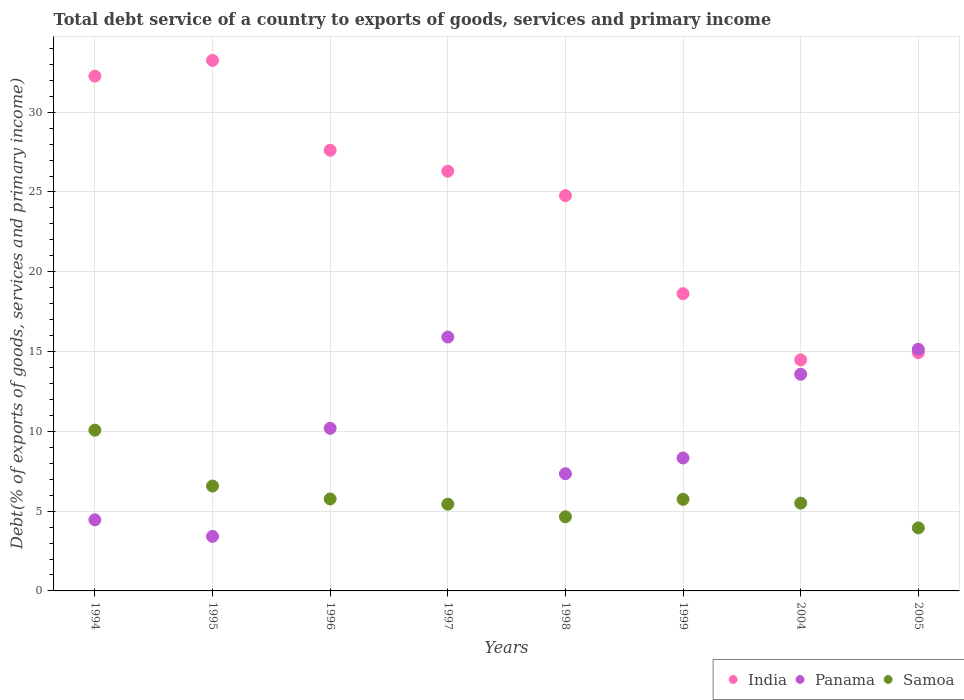How many different coloured dotlines are there?
Offer a very short reply. 3. What is the total debt service in Samoa in 2004?
Provide a succinct answer. 5.5. Across all years, what is the maximum total debt service in Samoa?
Provide a succinct answer. 10.07. Across all years, what is the minimum total debt service in India?
Make the answer very short. 14.48. In which year was the total debt service in Panama maximum?
Offer a terse response. 1997. In which year was the total debt service in Panama minimum?
Offer a terse response. 1995. What is the total total debt service in Panama in the graph?
Offer a terse response. 78.37. What is the difference between the total debt service in India in 1997 and that in 1998?
Make the answer very short. 1.53. What is the difference between the total debt service in Panama in 1998 and the total debt service in India in 1994?
Provide a succinct answer. -24.92. What is the average total debt service in India per year?
Make the answer very short. 24.03. In the year 1995, what is the difference between the total debt service in India and total debt service in Samoa?
Your answer should be very brief. 26.67. In how many years, is the total debt service in India greater than 1 %?
Your response must be concise. 8. What is the ratio of the total debt service in Panama in 1995 to that in 1997?
Make the answer very short. 0.21. Is the difference between the total debt service in India in 1998 and 2004 greater than the difference between the total debt service in Samoa in 1998 and 2004?
Provide a short and direct response. Yes. What is the difference between the highest and the second highest total debt service in India?
Your answer should be compact. 0.99. What is the difference between the highest and the lowest total debt service in Samoa?
Offer a terse response. 6.12. How many dotlines are there?
Your answer should be compact. 3. How many years are there in the graph?
Provide a succinct answer. 8. What is the difference between two consecutive major ticks on the Y-axis?
Give a very brief answer. 5. Are the values on the major ticks of Y-axis written in scientific E-notation?
Your answer should be very brief. No. Does the graph contain any zero values?
Give a very brief answer. No. What is the title of the graph?
Your answer should be very brief. Total debt service of a country to exports of goods, services and primary income. Does "Austria" appear as one of the legend labels in the graph?
Offer a terse response. No. What is the label or title of the Y-axis?
Ensure brevity in your answer.  Debt(% of exports of goods, services and primary income). What is the Debt(% of exports of goods, services and primary income) of India in 1994?
Ensure brevity in your answer.  32.26. What is the Debt(% of exports of goods, services and primary income) of Panama in 1994?
Provide a short and direct response. 4.46. What is the Debt(% of exports of goods, services and primary income) in Samoa in 1994?
Provide a short and direct response. 10.07. What is the Debt(% of exports of goods, services and primary income) of India in 1995?
Keep it short and to the point. 33.25. What is the Debt(% of exports of goods, services and primary income) in Panama in 1995?
Give a very brief answer. 3.42. What is the Debt(% of exports of goods, services and primary income) in Samoa in 1995?
Offer a very short reply. 6.57. What is the Debt(% of exports of goods, services and primary income) of India in 1996?
Make the answer very short. 27.62. What is the Debt(% of exports of goods, services and primary income) in Panama in 1996?
Your response must be concise. 10.19. What is the Debt(% of exports of goods, services and primary income) in Samoa in 1996?
Give a very brief answer. 5.76. What is the Debt(% of exports of goods, services and primary income) of India in 1997?
Offer a very short reply. 26.3. What is the Debt(% of exports of goods, services and primary income) in Panama in 1997?
Ensure brevity in your answer.  15.91. What is the Debt(% of exports of goods, services and primary income) in Samoa in 1997?
Your answer should be very brief. 5.44. What is the Debt(% of exports of goods, services and primary income) in India in 1998?
Your answer should be compact. 24.77. What is the Debt(% of exports of goods, services and primary income) of Panama in 1998?
Your answer should be compact. 7.35. What is the Debt(% of exports of goods, services and primary income) in Samoa in 1998?
Provide a succinct answer. 4.64. What is the Debt(% of exports of goods, services and primary income) in India in 1999?
Your response must be concise. 18.63. What is the Debt(% of exports of goods, services and primary income) of Panama in 1999?
Provide a succinct answer. 8.33. What is the Debt(% of exports of goods, services and primary income) in Samoa in 1999?
Keep it short and to the point. 5.74. What is the Debt(% of exports of goods, services and primary income) in India in 2004?
Ensure brevity in your answer.  14.48. What is the Debt(% of exports of goods, services and primary income) of Panama in 2004?
Make the answer very short. 13.58. What is the Debt(% of exports of goods, services and primary income) of Samoa in 2004?
Provide a succinct answer. 5.5. What is the Debt(% of exports of goods, services and primary income) of India in 2005?
Give a very brief answer. 14.93. What is the Debt(% of exports of goods, services and primary income) in Panama in 2005?
Give a very brief answer. 15.15. What is the Debt(% of exports of goods, services and primary income) of Samoa in 2005?
Your answer should be very brief. 3.95. Across all years, what is the maximum Debt(% of exports of goods, services and primary income) of India?
Keep it short and to the point. 33.25. Across all years, what is the maximum Debt(% of exports of goods, services and primary income) in Panama?
Provide a succinct answer. 15.91. Across all years, what is the maximum Debt(% of exports of goods, services and primary income) of Samoa?
Give a very brief answer. 10.07. Across all years, what is the minimum Debt(% of exports of goods, services and primary income) in India?
Give a very brief answer. 14.48. Across all years, what is the minimum Debt(% of exports of goods, services and primary income) in Panama?
Ensure brevity in your answer.  3.42. Across all years, what is the minimum Debt(% of exports of goods, services and primary income) of Samoa?
Keep it short and to the point. 3.95. What is the total Debt(% of exports of goods, services and primary income) in India in the graph?
Ensure brevity in your answer.  192.24. What is the total Debt(% of exports of goods, services and primary income) in Panama in the graph?
Your answer should be compact. 78.37. What is the total Debt(% of exports of goods, services and primary income) of Samoa in the graph?
Ensure brevity in your answer.  47.69. What is the difference between the Debt(% of exports of goods, services and primary income) of India in 1994 and that in 1995?
Keep it short and to the point. -0.99. What is the difference between the Debt(% of exports of goods, services and primary income) in Panama in 1994 and that in 1995?
Give a very brief answer. 1.04. What is the difference between the Debt(% of exports of goods, services and primary income) of Samoa in 1994 and that in 1995?
Give a very brief answer. 3.5. What is the difference between the Debt(% of exports of goods, services and primary income) in India in 1994 and that in 1996?
Your answer should be compact. 4.64. What is the difference between the Debt(% of exports of goods, services and primary income) in Panama in 1994 and that in 1996?
Provide a succinct answer. -5.73. What is the difference between the Debt(% of exports of goods, services and primary income) in Samoa in 1994 and that in 1996?
Your answer should be compact. 4.31. What is the difference between the Debt(% of exports of goods, services and primary income) in India in 1994 and that in 1997?
Offer a terse response. 5.96. What is the difference between the Debt(% of exports of goods, services and primary income) in Panama in 1994 and that in 1997?
Give a very brief answer. -11.46. What is the difference between the Debt(% of exports of goods, services and primary income) of Samoa in 1994 and that in 1997?
Ensure brevity in your answer.  4.64. What is the difference between the Debt(% of exports of goods, services and primary income) in India in 1994 and that in 1998?
Make the answer very short. 7.49. What is the difference between the Debt(% of exports of goods, services and primary income) of Panama in 1994 and that in 1998?
Give a very brief answer. -2.89. What is the difference between the Debt(% of exports of goods, services and primary income) of Samoa in 1994 and that in 1998?
Your answer should be very brief. 5.43. What is the difference between the Debt(% of exports of goods, services and primary income) of India in 1994 and that in 1999?
Offer a terse response. 13.63. What is the difference between the Debt(% of exports of goods, services and primary income) of Panama in 1994 and that in 1999?
Your answer should be compact. -3.88. What is the difference between the Debt(% of exports of goods, services and primary income) of Samoa in 1994 and that in 1999?
Keep it short and to the point. 4.33. What is the difference between the Debt(% of exports of goods, services and primary income) of India in 1994 and that in 2004?
Offer a very short reply. 17.78. What is the difference between the Debt(% of exports of goods, services and primary income) of Panama in 1994 and that in 2004?
Your response must be concise. -9.12. What is the difference between the Debt(% of exports of goods, services and primary income) of Samoa in 1994 and that in 2004?
Your answer should be compact. 4.57. What is the difference between the Debt(% of exports of goods, services and primary income) of India in 1994 and that in 2005?
Keep it short and to the point. 17.33. What is the difference between the Debt(% of exports of goods, services and primary income) of Panama in 1994 and that in 2005?
Give a very brief answer. -10.69. What is the difference between the Debt(% of exports of goods, services and primary income) of Samoa in 1994 and that in 2005?
Offer a terse response. 6.12. What is the difference between the Debt(% of exports of goods, services and primary income) of India in 1995 and that in 1996?
Keep it short and to the point. 5.63. What is the difference between the Debt(% of exports of goods, services and primary income) in Panama in 1995 and that in 1996?
Offer a terse response. -6.77. What is the difference between the Debt(% of exports of goods, services and primary income) of Samoa in 1995 and that in 1996?
Your response must be concise. 0.81. What is the difference between the Debt(% of exports of goods, services and primary income) of India in 1995 and that in 1997?
Keep it short and to the point. 6.95. What is the difference between the Debt(% of exports of goods, services and primary income) of Panama in 1995 and that in 1997?
Offer a terse response. -12.49. What is the difference between the Debt(% of exports of goods, services and primary income) of Samoa in 1995 and that in 1997?
Make the answer very short. 1.14. What is the difference between the Debt(% of exports of goods, services and primary income) in India in 1995 and that in 1998?
Offer a very short reply. 8.48. What is the difference between the Debt(% of exports of goods, services and primary income) of Panama in 1995 and that in 1998?
Your answer should be compact. -3.93. What is the difference between the Debt(% of exports of goods, services and primary income) in Samoa in 1995 and that in 1998?
Make the answer very short. 1.93. What is the difference between the Debt(% of exports of goods, services and primary income) in India in 1995 and that in 1999?
Offer a terse response. 14.62. What is the difference between the Debt(% of exports of goods, services and primary income) in Panama in 1995 and that in 1999?
Your answer should be very brief. -4.92. What is the difference between the Debt(% of exports of goods, services and primary income) of Samoa in 1995 and that in 1999?
Your answer should be compact. 0.83. What is the difference between the Debt(% of exports of goods, services and primary income) of India in 1995 and that in 2004?
Provide a succinct answer. 18.77. What is the difference between the Debt(% of exports of goods, services and primary income) in Panama in 1995 and that in 2004?
Provide a succinct answer. -10.16. What is the difference between the Debt(% of exports of goods, services and primary income) in Samoa in 1995 and that in 2004?
Offer a very short reply. 1.07. What is the difference between the Debt(% of exports of goods, services and primary income) in India in 1995 and that in 2005?
Your answer should be compact. 18.32. What is the difference between the Debt(% of exports of goods, services and primary income) of Panama in 1995 and that in 2005?
Your answer should be very brief. -11.73. What is the difference between the Debt(% of exports of goods, services and primary income) of Samoa in 1995 and that in 2005?
Keep it short and to the point. 2.62. What is the difference between the Debt(% of exports of goods, services and primary income) in India in 1996 and that in 1997?
Make the answer very short. 1.31. What is the difference between the Debt(% of exports of goods, services and primary income) of Panama in 1996 and that in 1997?
Provide a short and direct response. -5.72. What is the difference between the Debt(% of exports of goods, services and primary income) of Samoa in 1996 and that in 1997?
Keep it short and to the point. 0.33. What is the difference between the Debt(% of exports of goods, services and primary income) of India in 1996 and that in 1998?
Provide a succinct answer. 2.84. What is the difference between the Debt(% of exports of goods, services and primary income) of Panama in 1996 and that in 1998?
Keep it short and to the point. 2.84. What is the difference between the Debt(% of exports of goods, services and primary income) of Samoa in 1996 and that in 1998?
Offer a very short reply. 1.12. What is the difference between the Debt(% of exports of goods, services and primary income) of India in 1996 and that in 1999?
Offer a terse response. 8.99. What is the difference between the Debt(% of exports of goods, services and primary income) of Panama in 1996 and that in 1999?
Provide a short and direct response. 1.86. What is the difference between the Debt(% of exports of goods, services and primary income) of Samoa in 1996 and that in 1999?
Your answer should be compact. 0.02. What is the difference between the Debt(% of exports of goods, services and primary income) of India in 1996 and that in 2004?
Your answer should be compact. 13.14. What is the difference between the Debt(% of exports of goods, services and primary income) in Panama in 1996 and that in 2004?
Provide a succinct answer. -3.39. What is the difference between the Debt(% of exports of goods, services and primary income) of Samoa in 1996 and that in 2004?
Ensure brevity in your answer.  0.26. What is the difference between the Debt(% of exports of goods, services and primary income) in India in 1996 and that in 2005?
Give a very brief answer. 12.69. What is the difference between the Debt(% of exports of goods, services and primary income) in Panama in 1996 and that in 2005?
Your answer should be compact. -4.96. What is the difference between the Debt(% of exports of goods, services and primary income) of Samoa in 1996 and that in 2005?
Your answer should be compact. 1.81. What is the difference between the Debt(% of exports of goods, services and primary income) in India in 1997 and that in 1998?
Provide a succinct answer. 1.53. What is the difference between the Debt(% of exports of goods, services and primary income) of Panama in 1997 and that in 1998?
Your answer should be very brief. 8.57. What is the difference between the Debt(% of exports of goods, services and primary income) in Samoa in 1997 and that in 1998?
Your answer should be very brief. 0.79. What is the difference between the Debt(% of exports of goods, services and primary income) in India in 1997 and that in 1999?
Keep it short and to the point. 7.67. What is the difference between the Debt(% of exports of goods, services and primary income) of Panama in 1997 and that in 1999?
Offer a very short reply. 7.58. What is the difference between the Debt(% of exports of goods, services and primary income) in Samoa in 1997 and that in 1999?
Keep it short and to the point. -0.3. What is the difference between the Debt(% of exports of goods, services and primary income) of India in 1997 and that in 2004?
Offer a terse response. 11.82. What is the difference between the Debt(% of exports of goods, services and primary income) in Panama in 1997 and that in 2004?
Provide a short and direct response. 2.33. What is the difference between the Debt(% of exports of goods, services and primary income) of Samoa in 1997 and that in 2004?
Offer a terse response. -0.06. What is the difference between the Debt(% of exports of goods, services and primary income) in India in 1997 and that in 2005?
Offer a terse response. 11.37. What is the difference between the Debt(% of exports of goods, services and primary income) of Panama in 1997 and that in 2005?
Ensure brevity in your answer.  0.76. What is the difference between the Debt(% of exports of goods, services and primary income) in Samoa in 1997 and that in 2005?
Ensure brevity in your answer.  1.49. What is the difference between the Debt(% of exports of goods, services and primary income) in India in 1998 and that in 1999?
Offer a terse response. 6.15. What is the difference between the Debt(% of exports of goods, services and primary income) in Panama in 1998 and that in 1999?
Give a very brief answer. -0.99. What is the difference between the Debt(% of exports of goods, services and primary income) in Samoa in 1998 and that in 1999?
Keep it short and to the point. -1.1. What is the difference between the Debt(% of exports of goods, services and primary income) in India in 1998 and that in 2004?
Your answer should be compact. 10.29. What is the difference between the Debt(% of exports of goods, services and primary income) in Panama in 1998 and that in 2004?
Your answer should be compact. -6.23. What is the difference between the Debt(% of exports of goods, services and primary income) in Samoa in 1998 and that in 2004?
Offer a terse response. -0.86. What is the difference between the Debt(% of exports of goods, services and primary income) in India in 1998 and that in 2005?
Your answer should be compact. 9.84. What is the difference between the Debt(% of exports of goods, services and primary income) of Panama in 1998 and that in 2005?
Offer a terse response. -7.8. What is the difference between the Debt(% of exports of goods, services and primary income) of Samoa in 1998 and that in 2005?
Provide a short and direct response. 0.69. What is the difference between the Debt(% of exports of goods, services and primary income) of India in 1999 and that in 2004?
Provide a short and direct response. 4.15. What is the difference between the Debt(% of exports of goods, services and primary income) of Panama in 1999 and that in 2004?
Provide a succinct answer. -5.25. What is the difference between the Debt(% of exports of goods, services and primary income) of Samoa in 1999 and that in 2004?
Your response must be concise. 0.24. What is the difference between the Debt(% of exports of goods, services and primary income) in India in 1999 and that in 2005?
Keep it short and to the point. 3.7. What is the difference between the Debt(% of exports of goods, services and primary income) of Panama in 1999 and that in 2005?
Offer a very short reply. -6.81. What is the difference between the Debt(% of exports of goods, services and primary income) in Samoa in 1999 and that in 2005?
Provide a succinct answer. 1.79. What is the difference between the Debt(% of exports of goods, services and primary income) in India in 2004 and that in 2005?
Offer a terse response. -0.45. What is the difference between the Debt(% of exports of goods, services and primary income) in Panama in 2004 and that in 2005?
Your response must be concise. -1.57. What is the difference between the Debt(% of exports of goods, services and primary income) of Samoa in 2004 and that in 2005?
Provide a short and direct response. 1.55. What is the difference between the Debt(% of exports of goods, services and primary income) of India in 1994 and the Debt(% of exports of goods, services and primary income) of Panama in 1995?
Your response must be concise. 28.84. What is the difference between the Debt(% of exports of goods, services and primary income) of India in 1994 and the Debt(% of exports of goods, services and primary income) of Samoa in 1995?
Your answer should be very brief. 25.69. What is the difference between the Debt(% of exports of goods, services and primary income) in Panama in 1994 and the Debt(% of exports of goods, services and primary income) in Samoa in 1995?
Give a very brief answer. -2.12. What is the difference between the Debt(% of exports of goods, services and primary income) of India in 1994 and the Debt(% of exports of goods, services and primary income) of Panama in 1996?
Provide a short and direct response. 22.07. What is the difference between the Debt(% of exports of goods, services and primary income) in India in 1994 and the Debt(% of exports of goods, services and primary income) in Samoa in 1996?
Your answer should be very brief. 26.5. What is the difference between the Debt(% of exports of goods, services and primary income) of Panama in 1994 and the Debt(% of exports of goods, services and primary income) of Samoa in 1996?
Provide a succinct answer. -1.31. What is the difference between the Debt(% of exports of goods, services and primary income) in India in 1994 and the Debt(% of exports of goods, services and primary income) in Panama in 1997?
Keep it short and to the point. 16.35. What is the difference between the Debt(% of exports of goods, services and primary income) in India in 1994 and the Debt(% of exports of goods, services and primary income) in Samoa in 1997?
Make the answer very short. 26.82. What is the difference between the Debt(% of exports of goods, services and primary income) of Panama in 1994 and the Debt(% of exports of goods, services and primary income) of Samoa in 1997?
Keep it short and to the point. -0.98. What is the difference between the Debt(% of exports of goods, services and primary income) in India in 1994 and the Debt(% of exports of goods, services and primary income) in Panama in 1998?
Offer a very short reply. 24.92. What is the difference between the Debt(% of exports of goods, services and primary income) of India in 1994 and the Debt(% of exports of goods, services and primary income) of Samoa in 1998?
Your answer should be compact. 27.62. What is the difference between the Debt(% of exports of goods, services and primary income) of Panama in 1994 and the Debt(% of exports of goods, services and primary income) of Samoa in 1998?
Keep it short and to the point. -0.19. What is the difference between the Debt(% of exports of goods, services and primary income) in India in 1994 and the Debt(% of exports of goods, services and primary income) in Panama in 1999?
Ensure brevity in your answer.  23.93. What is the difference between the Debt(% of exports of goods, services and primary income) of India in 1994 and the Debt(% of exports of goods, services and primary income) of Samoa in 1999?
Your answer should be very brief. 26.52. What is the difference between the Debt(% of exports of goods, services and primary income) in Panama in 1994 and the Debt(% of exports of goods, services and primary income) in Samoa in 1999?
Your response must be concise. -1.28. What is the difference between the Debt(% of exports of goods, services and primary income) of India in 1994 and the Debt(% of exports of goods, services and primary income) of Panama in 2004?
Make the answer very short. 18.68. What is the difference between the Debt(% of exports of goods, services and primary income) in India in 1994 and the Debt(% of exports of goods, services and primary income) in Samoa in 2004?
Your response must be concise. 26.76. What is the difference between the Debt(% of exports of goods, services and primary income) in Panama in 1994 and the Debt(% of exports of goods, services and primary income) in Samoa in 2004?
Provide a short and direct response. -1.05. What is the difference between the Debt(% of exports of goods, services and primary income) in India in 1994 and the Debt(% of exports of goods, services and primary income) in Panama in 2005?
Provide a succinct answer. 17.11. What is the difference between the Debt(% of exports of goods, services and primary income) in India in 1994 and the Debt(% of exports of goods, services and primary income) in Samoa in 2005?
Make the answer very short. 28.31. What is the difference between the Debt(% of exports of goods, services and primary income) in Panama in 1994 and the Debt(% of exports of goods, services and primary income) in Samoa in 2005?
Your response must be concise. 0.51. What is the difference between the Debt(% of exports of goods, services and primary income) in India in 1995 and the Debt(% of exports of goods, services and primary income) in Panama in 1996?
Ensure brevity in your answer.  23.06. What is the difference between the Debt(% of exports of goods, services and primary income) of India in 1995 and the Debt(% of exports of goods, services and primary income) of Samoa in 1996?
Provide a succinct answer. 27.48. What is the difference between the Debt(% of exports of goods, services and primary income) in Panama in 1995 and the Debt(% of exports of goods, services and primary income) in Samoa in 1996?
Your answer should be very brief. -2.35. What is the difference between the Debt(% of exports of goods, services and primary income) of India in 1995 and the Debt(% of exports of goods, services and primary income) of Panama in 1997?
Your answer should be compact. 17.34. What is the difference between the Debt(% of exports of goods, services and primary income) in India in 1995 and the Debt(% of exports of goods, services and primary income) in Samoa in 1997?
Provide a succinct answer. 27.81. What is the difference between the Debt(% of exports of goods, services and primary income) in Panama in 1995 and the Debt(% of exports of goods, services and primary income) in Samoa in 1997?
Provide a succinct answer. -2.02. What is the difference between the Debt(% of exports of goods, services and primary income) in India in 1995 and the Debt(% of exports of goods, services and primary income) in Panama in 1998?
Give a very brief answer. 25.9. What is the difference between the Debt(% of exports of goods, services and primary income) of India in 1995 and the Debt(% of exports of goods, services and primary income) of Samoa in 1998?
Give a very brief answer. 28.6. What is the difference between the Debt(% of exports of goods, services and primary income) of Panama in 1995 and the Debt(% of exports of goods, services and primary income) of Samoa in 1998?
Provide a short and direct response. -1.23. What is the difference between the Debt(% of exports of goods, services and primary income) in India in 1995 and the Debt(% of exports of goods, services and primary income) in Panama in 1999?
Your answer should be compact. 24.92. What is the difference between the Debt(% of exports of goods, services and primary income) in India in 1995 and the Debt(% of exports of goods, services and primary income) in Samoa in 1999?
Provide a short and direct response. 27.51. What is the difference between the Debt(% of exports of goods, services and primary income) in Panama in 1995 and the Debt(% of exports of goods, services and primary income) in Samoa in 1999?
Offer a very short reply. -2.32. What is the difference between the Debt(% of exports of goods, services and primary income) in India in 1995 and the Debt(% of exports of goods, services and primary income) in Panama in 2004?
Give a very brief answer. 19.67. What is the difference between the Debt(% of exports of goods, services and primary income) in India in 1995 and the Debt(% of exports of goods, services and primary income) in Samoa in 2004?
Offer a terse response. 27.75. What is the difference between the Debt(% of exports of goods, services and primary income) in Panama in 1995 and the Debt(% of exports of goods, services and primary income) in Samoa in 2004?
Make the answer very short. -2.09. What is the difference between the Debt(% of exports of goods, services and primary income) in India in 1995 and the Debt(% of exports of goods, services and primary income) in Panama in 2005?
Provide a short and direct response. 18.1. What is the difference between the Debt(% of exports of goods, services and primary income) of India in 1995 and the Debt(% of exports of goods, services and primary income) of Samoa in 2005?
Offer a terse response. 29.3. What is the difference between the Debt(% of exports of goods, services and primary income) of Panama in 1995 and the Debt(% of exports of goods, services and primary income) of Samoa in 2005?
Offer a terse response. -0.53. What is the difference between the Debt(% of exports of goods, services and primary income) of India in 1996 and the Debt(% of exports of goods, services and primary income) of Panama in 1997?
Keep it short and to the point. 11.7. What is the difference between the Debt(% of exports of goods, services and primary income) of India in 1996 and the Debt(% of exports of goods, services and primary income) of Samoa in 1997?
Your response must be concise. 22.18. What is the difference between the Debt(% of exports of goods, services and primary income) of Panama in 1996 and the Debt(% of exports of goods, services and primary income) of Samoa in 1997?
Keep it short and to the point. 4.75. What is the difference between the Debt(% of exports of goods, services and primary income) in India in 1996 and the Debt(% of exports of goods, services and primary income) in Panama in 1998?
Provide a short and direct response. 20.27. What is the difference between the Debt(% of exports of goods, services and primary income) of India in 1996 and the Debt(% of exports of goods, services and primary income) of Samoa in 1998?
Make the answer very short. 22.97. What is the difference between the Debt(% of exports of goods, services and primary income) of Panama in 1996 and the Debt(% of exports of goods, services and primary income) of Samoa in 1998?
Your answer should be compact. 5.54. What is the difference between the Debt(% of exports of goods, services and primary income) of India in 1996 and the Debt(% of exports of goods, services and primary income) of Panama in 1999?
Give a very brief answer. 19.28. What is the difference between the Debt(% of exports of goods, services and primary income) of India in 1996 and the Debt(% of exports of goods, services and primary income) of Samoa in 1999?
Provide a succinct answer. 21.88. What is the difference between the Debt(% of exports of goods, services and primary income) in Panama in 1996 and the Debt(% of exports of goods, services and primary income) in Samoa in 1999?
Ensure brevity in your answer.  4.45. What is the difference between the Debt(% of exports of goods, services and primary income) of India in 1996 and the Debt(% of exports of goods, services and primary income) of Panama in 2004?
Your answer should be very brief. 14.04. What is the difference between the Debt(% of exports of goods, services and primary income) in India in 1996 and the Debt(% of exports of goods, services and primary income) in Samoa in 2004?
Your answer should be very brief. 22.11. What is the difference between the Debt(% of exports of goods, services and primary income) in Panama in 1996 and the Debt(% of exports of goods, services and primary income) in Samoa in 2004?
Your answer should be very brief. 4.69. What is the difference between the Debt(% of exports of goods, services and primary income) in India in 1996 and the Debt(% of exports of goods, services and primary income) in Panama in 2005?
Keep it short and to the point. 12.47. What is the difference between the Debt(% of exports of goods, services and primary income) of India in 1996 and the Debt(% of exports of goods, services and primary income) of Samoa in 2005?
Give a very brief answer. 23.67. What is the difference between the Debt(% of exports of goods, services and primary income) in Panama in 1996 and the Debt(% of exports of goods, services and primary income) in Samoa in 2005?
Provide a succinct answer. 6.24. What is the difference between the Debt(% of exports of goods, services and primary income) of India in 1997 and the Debt(% of exports of goods, services and primary income) of Panama in 1998?
Offer a very short reply. 18.96. What is the difference between the Debt(% of exports of goods, services and primary income) in India in 1997 and the Debt(% of exports of goods, services and primary income) in Samoa in 1998?
Offer a very short reply. 21.66. What is the difference between the Debt(% of exports of goods, services and primary income) in Panama in 1997 and the Debt(% of exports of goods, services and primary income) in Samoa in 1998?
Give a very brief answer. 11.27. What is the difference between the Debt(% of exports of goods, services and primary income) of India in 1997 and the Debt(% of exports of goods, services and primary income) of Panama in 1999?
Your answer should be compact. 17.97. What is the difference between the Debt(% of exports of goods, services and primary income) of India in 1997 and the Debt(% of exports of goods, services and primary income) of Samoa in 1999?
Provide a succinct answer. 20.56. What is the difference between the Debt(% of exports of goods, services and primary income) in Panama in 1997 and the Debt(% of exports of goods, services and primary income) in Samoa in 1999?
Offer a terse response. 10.17. What is the difference between the Debt(% of exports of goods, services and primary income) in India in 1997 and the Debt(% of exports of goods, services and primary income) in Panama in 2004?
Offer a terse response. 12.72. What is the difference between the Debt(% of exports of goods, services and primary income) of India in 1997 and the Debt(% of exports of goods, services and primary income) of Samoa in 2004?
Ensure brevity in your answer.  20.8. What is the difference between the Debt(% of exports of goods, services and primary income) in Panama in 1997 and the Debt(% of exports of goods, services and primary income) in Samoa in 2004?
Offer a terse response. 10.41. What is the difference between the Debt(% of exports of goods, services and primary income) of India in 1997 and the Debt(% of exports of goods, services and primary income) of Panama in 2005?
Your answer should be compact. 11.16. What is the difference between the Debt(% of exports of goods, services and primary income) in India in 1997 and the Debt(% of exports of goods, services and primary income) in Samoa in 2005?
Offer a very short reply. 22.35. What is the difference between the Debt(% of exports of goods, services and primary income) of Panama in 1997 and the Debt(% of exports of goods, services and primary income) of Samoa in 2005?
Offer a terse response. 11.96. What is the difference between the Debt(% of exports of goods, services and primary income) in India in 1998 and the Debt(% of exports of goods, services and primary income) in Panama in 1999?
Provide a short and direct response. 16.44. What is the difference between the Debt(% of exports of goods, services and primary income) of India in 1998 and the Debt(% of exports of goods, services and primary income) of Samoa in 1999?
Offer a very short reply. 19.03. What is the difference between the Debt(% of exports of goods, services and primary income) of Panama in 1998 and the Debt(% of exports of goods, services and primary income) of Samoa in 1999?
Offer a terse response. 1.6. What is the difference between the Debt(% of exports of goods, services and primary income) of India in 1998 and the Debt(% of exports of goods, services and primary income) of Panama in 2004?
Offer a terse response. 11.19. What is the difference between the Debt(% of exports of goods, services and primary income) of India in 1998 and the Debt(% of exports of goods, services and primary income) of Samoa in 2004?
Provide a succinct answer. 19.27. What is the difference between the Debt(% of exports of goods, services and primary income) in Panama in 1998 and the Debt(% of exports of goods, services and primary income) in Samoa in 2004?
Your answer should be very brief. 1.84. What is the difference between the Debt(% of exports of goods, services and primary income) of India in 1998 and the Debt(% of exports of goods, services and primary income) of Panama in 2005?
Give a very brief answer. 9.63. What is the difference between the Debt(% of exports of goods, services and primary income) in India in 1998 and the Debt(% of exports of goods, services and primary income) in Samoa in 2005?
Make the answer very short. 20.82. What is the difference between the Debt(% of exports of goods, services and primary income) in Panama in 1998 and the Debt(% of exports of goods, services and primary income) in Samoa in 2005?
Offer a very short reply. 3.4. What is the difference between the Debt(% of exports of goods, services and primary income) of India in 1999 and the Debt(% of exports of goods, services and primary income) of Panama in 2004?
Your response must be concise. 5.05. What is the difference between the Debt(% of exports of goods, services and primary income) of India in 1999 and the Debt(% of exports of goods, services and primary income) of Samoa in 2004?
Make the answer very short. 13.12. What is the difference between the Debt(% of exports of goods, services and primary income) in Panama in 1999 and the Debt(% of exports of goods, services and primary income) in Samoa in 2004?
Offer a very short reply. 2.83. What is the difference between the Debt(% of exports of goods, services and primary income) in India in 1999 and the Debt(% of exports of goods, services and primary income) in Panama in 2005?
Ensure brevity in your answer.  3.48. What is the difference between the Debt(% of exports of goods, services and primary income) in India in 1999 and the Debt(% of exports of goods, services and primary income) in Samoa in 2005?
Your answer should be compact. 14.68. What is the difference between the Debt(% of exports of goods, services and primary income) of Panama in 1999 and the Debt(% of exports of goods, services and primary income) of Samoa in 2005?
Give a very brief answer. 4.38. What is the difference between the Debt(% of exports of goods, services and primary income) of India in 2004 and the Debt(% of exports of goods, services and primary income) of Panama in 2005?
Your answer should be compact. -0.67. What is the difference between the Debt(% of exports of goods, services and primary income) in India in 2004 and the Debt(% of exports of goods, services and primary income) in Samoa in 2005?
Offer a very short reply. 10.53. What is the difference between the Debt(% of exports of goods, services and primary income) of Panama in 2004 and the Debt(% of exports of goods, services and primary income) of Samoa in 2005?
Provide a short and direct response. 9.63. What is the average Debt(% of exports of goods, services and primary income) in India per year?
Offer a terse response. 24.03. What is the average Debt(% of exports of goods, services and primary income) in Panama per year?
Your answer should be very brief. 9.8. What is the average Debt(% of exports of goods, services and primary income) in Samoa per year?
Provide a short and direct response. 5.96. In the year 1994, what is the difference between the Debt(% of exports of goods, services and primary income) in India and Debt(% of exports of goods, services and primary income) in Panama?
Provide a short and direct response. 27.81. In the year 1994, what is the difference between the Debt(% of exports of goods, services and primary income) of India and Debt(% of exports of goods, services and primary income) of Samoa?
Keep it short and to the point. 22.19. In the year 1994, what is the difference between the Debt(% of exports of goods, services and primary income) in Panama and Debt(% of exports of goods, services and primary income) in Samoa?
Offer a very short reply. -5.62. In the year 1995, what is the difference between the Debt(% of exports of goods, services and primary income) in India and Debt(% of exports of goods, services and primary income) in Panama?
Offer a very short reply. 29.83. In the year 1995, what is the difference between the Debt(% of exports of goods, services and primary income) of India and Debt(% of exports of goods, services and primary income) of Samoa?
Keep it short and to the point. 26.67. In the year 1995, what is the difference between the Debt(% of exports of goods, services and primary income) of Panama and Debt(% of exports of goods, services and primary income) of Samoa?
Offer a very short reply. -3.16. In the year 1996, what is the difference between the Debt(% of exports of goods, services and primary income) of India and Debt(% of exports of goods, services and primary income) of Panama?
Provide a short and direct response. 17.43. In the year 1996, what is the difference between the Debt(% of exports of goods, services and primary income) in India and Debt(% of exports of goods, services and primary income) in Samoa?
Make the answer very short. 21.85. In the year 1996, what is the difference between the Debt(% of exports of goods, services and primary income) of Panama and Debt(% of exports of goods, services and primary income) of Samoa?
Keep it short and to the point. 4.43. In the year 1997, what is the difference between the Debt(% of exports of goods, services and primary income) in India and Debt(% of exports of goods, services and primary income) in Panama?
Give a very brief answer. 10.39. In the year 1997, what is the difference between the Debt(% of exports of goods, services and primary income) of India and Debt(% of exports of goods, services and primary income) of Samoa?
Make the answer very short. 20.86. In the year 1997, what is the difference between the Debt(% of exports of goods, services and primary income) of Panama and Debt(% of exports of goods, services and primary income) of Samoa?
Provide a short and direct response. 10.47. In the year 1998, what is the difference between the Debt(% of exports of goods, services and primary income) of India and Debt(% of exports of goods, services and primary income) of Panama?
Your answer should be very brief. 17.43. In the year 1998, what is the difference between the Debt(% of exports of goods, services and primary income) in India and Debt(% of exports of goods, services and primary income) in Samoa?
Give a very brief answer. 20.13. In the year 1998, what is the difference between the Debt(% of exports of goods, services and primary income) of Panama and Debt(% of exports of goods, services and primary income) of Samoa?
Make the answer very short. 2.7. In the year 1999, what is the difference between the Debt(% of exports of goods, services and primary income) of India and Debt(% of exports of goods, services and primary income) of Panama?
Provide a short and direct response. 10.29. In the year 1999, what is the difference between the Debt(% of exports of goods, services and primary income) of India and Debt(% of exports of goods, services and primary income) of Samoa?
Give a very brief answer. 12.89. In the year 1999, what is the difference between the Debt(% of exports of goods, services and primary income) in Panama and Debt(% of exports of goods, services and primary income) in Samoa?
Keep it short and to the point. 2.59. In the year 2004, what is the difference between the Debt(% of exports of goods, services and primary income) in India and Debt(% of exports of goods, services and primary income) in Panama?
Provide a succinct answer. 0.9. In the year 2004, what is the difference between the Debt(% of exports of goods, services and primary income) of India and Debt(% of exports of goods, services and primary income) of Samoa?
Ensure brevity in your answer.  8.98. In the year 2004, what is the difference between the Debt(% of exports of goods, services and primary income) in Panama and Debt(% of exports of goods, services and primary income) in Samoa?
Provide a succinct answer. 8.08. In the year 2005, what is the difference between the Debt(% of exports of goods, services and primary income) of India and Debt(% of exports of goods, services and primary income) of Panama?
Offer a terse response. -0.22. In the year 2005, what is the difference between the Debt(% of exports of goods, services and primary income) of India and Debt(% of exports of goods, services and primary income) of Samoa?
Your response must be concise. 10.98. In the year 2005, what is the difference between the Debt(% of exports of goods, services and primary income) of Panama and Debt(% of exports of goods, services and primary income) of Samoa?
Provide a short and direct response. 11.2. What is the ratio of the Debt(% of exports of goods, services and primary income) of India in 1994 to that in 1995?
Keep it short and to the point. 0.97. What is the ratio of the Debt(% of exports of goods, services and primary income) in Panama in 1994 to that in 1995?
Make the answer very short. 1.3. What is the ratio of the Debt(% of exports of goods, services and primary income) of Samoa in 1994 to that in 1995?
Make the answer very short. 1.53. What is the ratio of the Debt(% of exports of goods, services and primary income) of India in 1994 to that in 1996?
Make the answer very short. 1.17. What is the ratio of the Debt(% of exports of goods, services and primary income) in Panama in 1994 to that in 1996?
Your answer should be very brief. 0.44. What is the ratio of the Debt(% of exports of goods, services and primary income) of Samoa in 1994 to that in 1996?
Keep it short and to the point. 1.75. What is the ratio of the Debt(% of exports of goods, services and primary income) of India in 1994 to that in 1997?
Ensure brevity in your answer.  1.23. What is the ratio of the Debt(% of exports of goods, services and primary income) in Panama in 1994 to that in 1997?
Provide a succinct answer. 0.28. What is the ratio of the Debt(% of exports of goods, services and primary income) of Samoa in 1994 to that in 1997?
Make the answer very short. 1.85. What is the ratio of the Debt(% of exports of goods, services and primary income) in India in 1994 to that in 1998?
Your response must be concise. 1.3. What is the ratio of the Debt(% of exports of goods, services and primary income) of Panama in 1994 to that in 1998?
Provide a succinct answer. 0.61. What is the ratio of the Debt(% of exports of goods, services and primary income) of Samoa in 1994 to that in 1998?
Give a very brief answer. 2.17. What is the ratio of the Debt(% of exports of goods, services and primary income) of India in 1994 to that in 1999?
Keep it short and to the point. 1.73. What is the ratio of the Debt(% of exports of goods, services and primary income) in Panama in 1994 to that in 1999?
Your response must be concise. 0.53. What is the ratio of the Debt(% of exports of goods, services and primary income) in Samoa in 1994 to that in 1999?
Offer a very short reply. 1.75. What is the ratio of the Debt(% of exports of goods, services and primary income) of India in 1994 to that in 2004?
Provide a short and direct response. 2.23. What is the ratio of the Debt(% of exports of goods, services and primary income) in Panama in 1994 to that in 2004?
Ensure brevity in your answer.  0.33. What is the ratio of the Debt(% of exports of goods, services and primary income) in Samoa in 1994 to that in 2004?
Offer a very short reply. 1.83. What is the ratio of the Debt(% of exports of goods, services and primary income) of India in 1994 to that in 2005?
Ensure brevity in your answer.  2.16. What is the ratio of the Debt(% of exports of goods, services and primary income) in Panama in 1994 to that in 2005?
Make the answer very short. 0.29. What is the ratio of the Debt(% of exports of goods, services and primary income) of Samoa in 1994 to that in 2005?
Make the answer very short. 2.55. What is the ratio of the Debt(% of exports of goods, services and primary income) of India in 1995 to that in 1996?
Provide a succinct answer. 1.2. What is the ratio of the Debt(% of exports of goods, services and primary income) of Panama in 1995 to that in 1996?
Your answer should be compact. 0.34. What is the ratio of the Debt(% of exports of goods, services and primary income) in Samoa in 1995 to that in 1996?
Your answer should be very brief. 1.14. What is the ratio of the Debt(% of exports of goods, services and primary income) of India in 1995 to that in 1997?
Your response must be concise. 1.26. What is the ratio of the Debt(% of exports of goods, services and primary income) of Panama in 1995 to that in 1997?
Your response must be concise. 0.21. What is the ratio of the Debt(% of exports of goods, services and primary income) of Samoa in 1995 to that in 1997?
Offer a terse response. 1.21. What is the ratio of the Debt(% of exports of goods, services and primary income) in India in 1995 to that in 1998?
Ensure brevity in your answer.  1.34. What is the ratio of the Debt(% of exports of goods, services and primary income) of Panama in 1995 to that in 1998?
Your answer should be compact. 0.47. What is the ratio of the Debt(% of exports of goods, services and primary income) of Samoa in 1995 to that in 1998?
Your response must be concise. 1.42. What is the ratio of the Debt(% of exports of goods, services and primary income) in India in 1995 to that in 1999?
Provide a short and direct response. 1.78. What is the ratio of the Debt(% of exports of goods, services and primary income) of Panama in 1995 to that in 1999?
Offer a very short reply. 0.41. What is the ratio of the Debt(% of exports of goods, services and primary income) of Samoa in 1995 to that in 1999?
Your answer should be very brief. 1.15. What is the ratio of the Debt(% of exports of goods, services and primary income) in India in 1995 to that in 2004?
Offer a very short reply. 2.3. What is the ratio of the Debt(% of exports of goods, services and primary income) of Panama in 1995 to that in 2004?
Your response must be concise. 0.25. What is the ratio of the Debt(% of exports of goods, services and primary income) of Samoa in 1995 to that in 2004?
Your response must be concise. 1.19. What is the ratio of the Debt(% of exports of goods, services and primary income) of India in 1995 to that in 2005?
Ensure brevity in your answer.  2.23. What is the ratio of the Debt(% of exports of goods, services and primary income) in Panama in 1995 to that in 2005?
Provide a succinct answer. 0.23. What is the ratio of the Debt(% of exports of goods, services and primary income) in Samoa in 1995 to that in 2005?
Provide a succinct answer. 1.66. What is the ratio of the Debt(% of exports of goods, services and primary income) of India in 1996 to that in 1997?
Offer a very short reply. 1.05. What is the ratio of the Debt(% of exports of goods, services and primary income) of Panama in 1996 to that in 1997?
Offer a very short reply. 0.64. What is the ratio of the Debt(% of exports of goods, services and primary income) in Samoa in 1996 to that in 1997?
Your answer should be compact. 1.06. What is the ratio of the Debt(% of exports of goods, services and primary income) in India in 1996 to that in 1998?
Make the answer very short. 1.11. What is the ratio of the Debt(% of exports of goods, services and primary income) in Panama in 1996 to that in 1998?
Offer a terse response. 1.39. What is the ratio of the Debt(% of exports of goods, services and primary income) in Samoa in 1996 to that in 1998?
Your answer should be compact. 1.24. What is the ratio of the Debt(% of exports of goods, services and primary income) in India in 1996 to that in 1999?
Make the answer very short. 1.48. What is the ratio of the Debt(% of exports of goods, services and primary income) of Panama in 1996 to that in 1999?
Make the answer very short. 1.22. What is the ratio of the Debt(% of exports of goods, services and primary income) in Samoa in 1996 to that in 1999?
Offer a very short reply. 1. What is the ratio of the Debt(% of exports of goods, services and primary income) of India in 1996 to that in 2004?
Give a very brief answer. 1.91. What is the ratio of the Debt(% of exports of goods, services and primary income) of Panama in 1996 to that in 2004?
Keep it short and to the point. 0.75. What is the ratio of the Debt(% of exports of goods, services and primary income) in Samoa in 1996 to that in 2004?
Your answer should be compact. 1.05. What is the ratio of the Debt(% of exports of goods, services and primary income) in India in 1996 to that in 2005?
Your answer should be very brief. 1.85. What is the ratio of the Debt(% of exports of goods, services and primary income) of Panama in 1996 to that in 2005?
Your response must be concise. 0.67. What is the ratio of the Debt(% of exports of goods, services and primary income) of Samoa in 1996 to that in 2005?
Provide a succinct answer. 1.46. What is the ratio of the Debt(% of exports of goods, services and primary income) in India in 1997 to that in 1998?
Provide a succinct answer. 1.06. What is the ratio of the Debt(% of exports of goods, services and primary income) of Panama in 1997 to that in 1998?
Give a very brief answer. 2.17. What is the ratio of the Debt(% of exports of goods, services and primary income) of Samoa in 1997 to that in 1998?
Your response must be concise. 1.17. What is the ratio of the Debt(% of exports of goods, services and primary income) of India in 1997 to that in 1999?
Your answer should be very brief. 1.41. What is the ratio of the Debt(% of exports of goods, services and primary income) of Panama in 1997 to that in 1999?
Ensure brevity in your answer.  1.91. What is the ratio of the Debt(% of exports of goods, services and primary income) of Samoa in 1997 to that in 1999?
Provide a short and direct response. 0.95. What is the ratio of the Debt(% of exports of goods, services and primary income) in India in 1997 to that in 2004?
Keep it short and to the point. 1.82. What is the ratio of the Debt(% of exports of goods, services and primary income) of Panama in 1997 to that in 2004?
Give a very brief answer. 1.17. What is the ratio of the Debt(% of exports of goods, services and primary income) in Samoa in 1997 to that in 2004?
Offer a terse response. 0.99. What is the ratio of the Debt(% of exports of goods, services and primary income) in India in 1997 to that in 2005?
Keep it short and to the point. 1.76. What is the ratio of the Debt(% of exports of goods, services and primary income) of Panama in 1997 to that in 2005?
Provide a short and direct response. 1.05. What is the ratio of the Debt(% of exports of goods, services and primary income) of Samoa in 1997 to that in 2005?
Offer a terse response. 1.38. What is the ratio of the Debt(% of exports of goods, services and primary income) of India in 1998 to that in 1999?
Offer a very short reply. 1.33. What is the ratio of the Debt(% of exports of goods, services and primary income) of Panama in 1998 to that in 1999?
Give a very brief answer. 0.88. What is the ratio of the Debt(% of exports of goods, services and primary income) in Samoa in 1998 to that in 1999?
Keep it short and to the point. 0.81. What is the ratio of the Debt(% of exports of goods, services and primary income) in India in 1998 to that in 2004?
Ensure brevity in your answer.  1.71. What is the ratio of the Debt(% of exports of goods, services and primary income) in Panama in 1998 to that in 2004?
Ensure brevity in your answer.  0.54. What is the ratio of the Debt(% of exports of goods, services and primary income) of Samoa in 1998 to that in 2004?
Ensure brevity in your answer.  0.84. What is the ratio of the Debt(% of exports of goods, services and primary income) in India in 1998 to that in 2005?
Keep it short and to the point. 1.66. What is the ratio of the Debt(% of exports of goods, services and primary income) in Panama in 1998 to that in 2005?
Your answer should be compact. 0.48. What is the ratio of the Debt(% of exports of goods, services and primary income) in Samoa in 1998 to that in 2005?
Offer a very short reply. 1.18. What is the ratio of the Debt(% of exports of goods, services and primary income) of India in 1999 to that in 2004?
Keep it short and to the point. 1.29. What is the ratio of the Debt(% of exports of goods, services and primary income) of Panama in 1999 to that in 2004?
Your answer should be very brief. 0.61. What is the ratio of the Debt(% of exports of goods, services and primary income) in Samoa in 1999 to that in 2004?
Your response must be concise. 1.04. What is the ratio of the Debt(% of exports of goods, services and primary income) in India in 1999 to that in 2005?
Your answer should be compact. 1.25. What is the ratio of the Debt(% of exports of goods, services and primary income) in Panama in 1999 to that in 2005?
Offer a terse response. 0.55. What is the ratio of the Debt(% of exports of goods, services and primary income) of Samoa in 1999 to that in 2005?
Offer a very short reply. 1.45. What is the ratio of the Debt(% of exports of goods, services and primary income) of India in 2004 to that in 2005?
Offer a very short reply. 0.97. What is the ratio of the Debt(% of exports of goods, services and primary income) of Panama in 2004 to that in 2005?
Give a very brief answer. 0.9. What is the ratio of the Debt(% of exports of goods, services and primary income) in Samoa in 2004 to that in 2005?
Provide a succinct answer. 1.39. What is the difference between the highest and the second highest Debt(% of exports of goods, services and primary income) in India?
Provide a succinct answer. 0.99. What is the difference between the highest and the second highest Debt(% of exports of goods, services and primary income) of Panama?
Make the answer very short. 0.76. What is the difference between the highest and the second highest Debt(% of exports of goods, services and primary income) in Samoa?
Make the answer very short. 3.5. What is the difference between the highest and the lowest Debt(% of exports of goods, services and primary income) of India?
Your answer should be compact. 18.77. What is the difference between the highest and the lowest Debt(% of exports of goods, services and primary income) of Panama?
Provide a succinct answer. 12.49. What is the difference between the highest and the lowest Debt(% of exports of goods, services and primary income) in Samoa?
Offer a terse response. 6.12. 